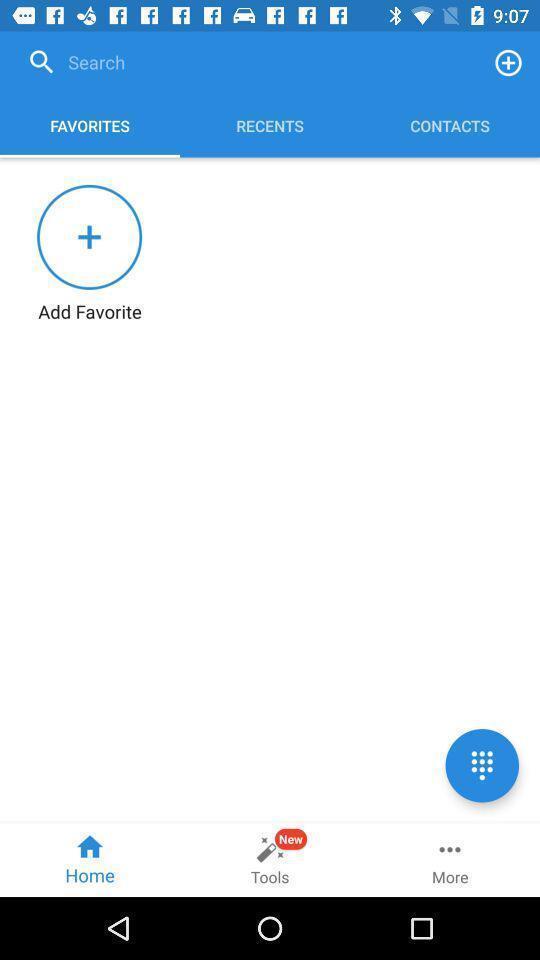Describe the key features of this screenshot. Search options to favorites and recents and contacts. 